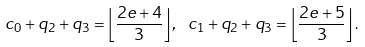Convert formula to latex. <formula><loc_0><loc_0><loc_500><loc_500>c _ { 0 } + q _ { 2 } + q _ { 3 } = \left \lfloor \frac { 2 e + 4 } { 3 } \right \rfloor , { \ } c _ { 1 } + q _ { 2 } + q _ { 3 } = \left \lfloor \frac { 2 e + 5 } { 3 } \right \rfloor .</formula> 